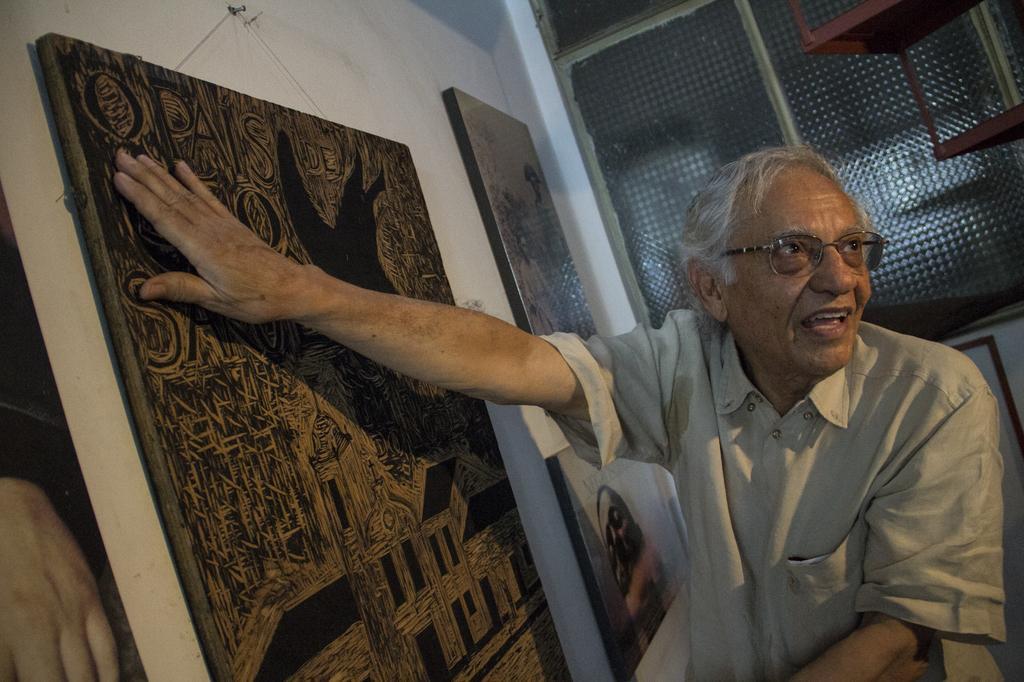In one or two sentences, can you explain what this image depicts? In the foreground, I can see a man is touching wall paintings, which are hanged on a wall. In the background, I can see metal objects, window and so on. This picture might be taken in a hall. 